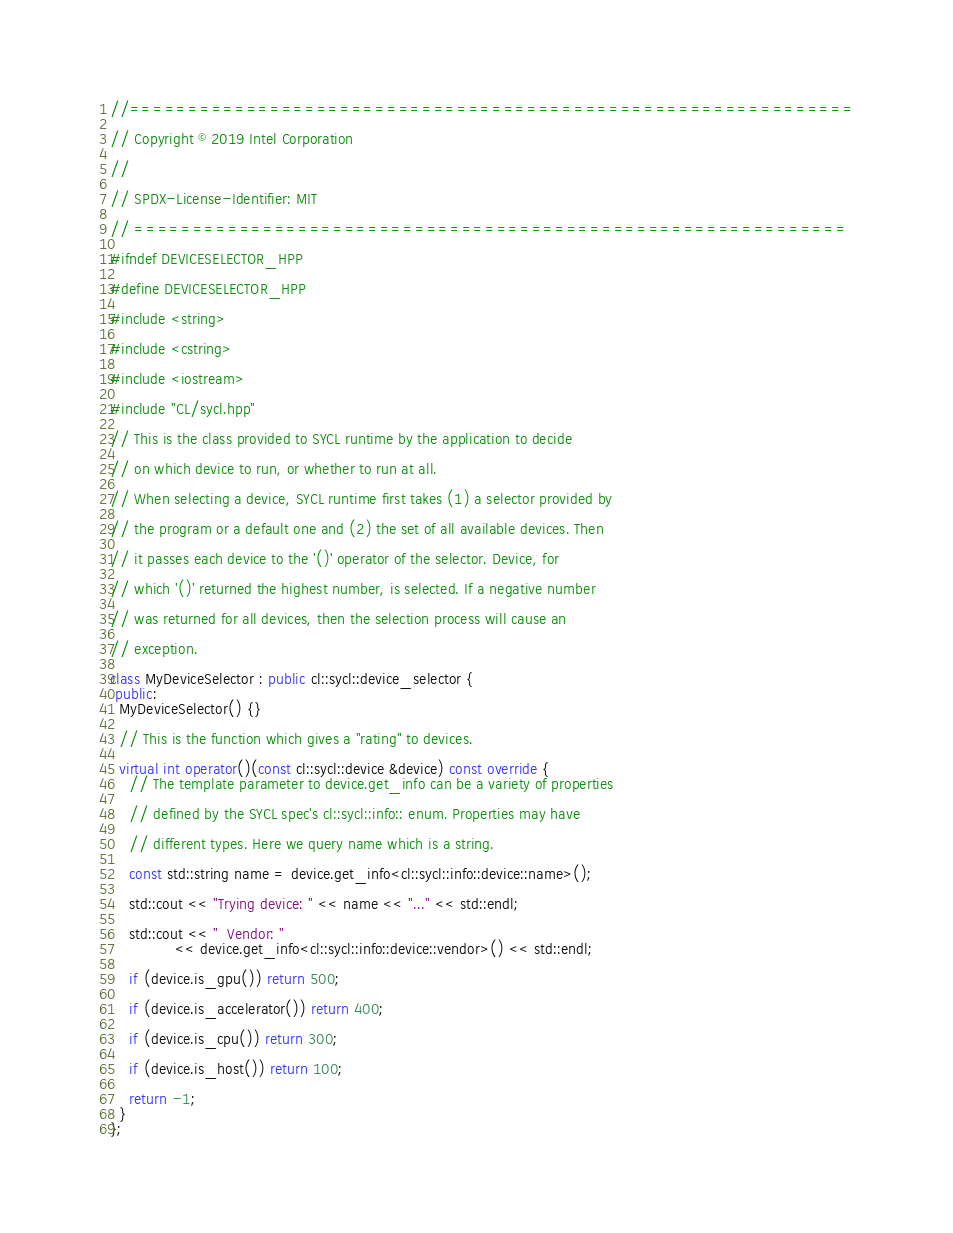Convert code to text. <code><loc_0><loc_0><loc_500><loc_500><_C++_>//==============================================================

// Copyright © 2019 Intel Corporation

//

// SPDX-License-Identifier: MIT

// =============================================================

#ifndef DEVICESELECTOR_HPP

#define DEVICESELECTOR_HPP

#include <string>

#include <cstring>

#include <iostream>

#include "CL/sycl.hpp"

// This is the class provided to SYCL runtime by the application to decide

// on which device to run, or whether to run at all.

// When selecting a device, SYCL runtime first takes (1) a selector provided by

// the program or a default one and (2) the set of all available devices. Then

// it passes each device to the '()' operator of the selector. Device, for

// which '()' returned the highest number, is selected. If a negative number

// was returned for all devices, then the selection process will cause an

// exception.

class MyDeviceSelector : public cl::sycl::device_selector {
 public:
  MyDeviceSelector() {}

  // This is the function which gives a "rating" to devices.

  virtual int operator()(const cl::sycl::device &device) const override {
    // The template parameter to device.get_info can be a variety of properties

    // defined by the SYCL spec's cl::sycl::info:: enum. Properties may have

    // different types. Here we query name which is a string.

    const std::string name = device.get_info<cl::sycl::info::device::name>();

    std::cout << "Trying device: " << name << "..." << std::endl;

    std::cout << "  Vendor: "
              << device.get_info<cl::sycl::info::device::vendor>() << std::endl;

    if (device.is_gpu()) return 500;

    if (device.is_accelerator()) return 400;

    if (device.is_cpu()) return 300;

    if (device.is_host()) return 100;

    return -1;
  }
};
</code> 